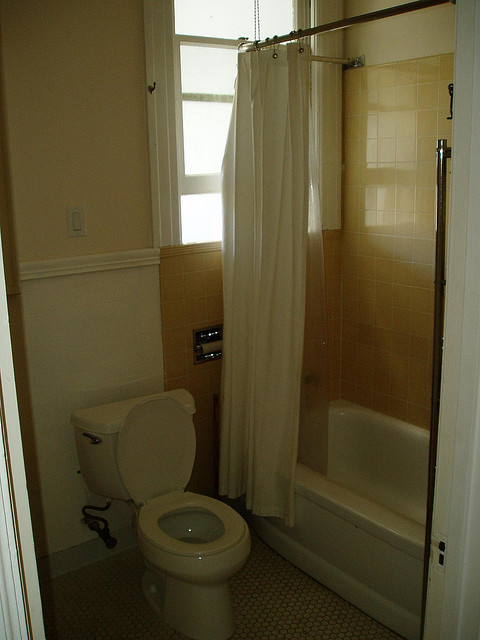<image>What shape are the floor tiles? I am not sure about the shape of the floor tiles. It could be square, pentagon, octagon, hexagonal, or diamond. What is the motif on the shower curtain? It is not clear what the motif on the shower curtain is, but it can be plain white. Which city is this house in? It is unclear which city this house is located in. What shape are the floor tiles? I am not sure what shape the floor tiles are. It can be seen square, pentagon, octagon, hexagonal or diamond. What is the motif on the shower curtain? I don't know what the motif is on the shower curtain. It can be plain white, plain, or solid white. Which city is this house in? I don't know which city this house is in. It can be either New York City, NY, Atlanta, Boston, London, or LA. 